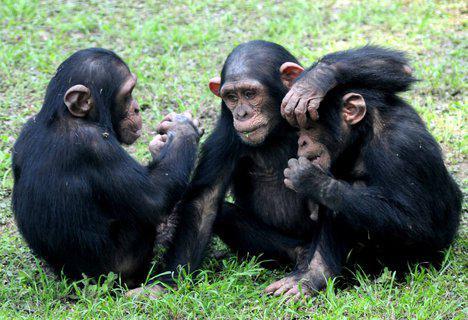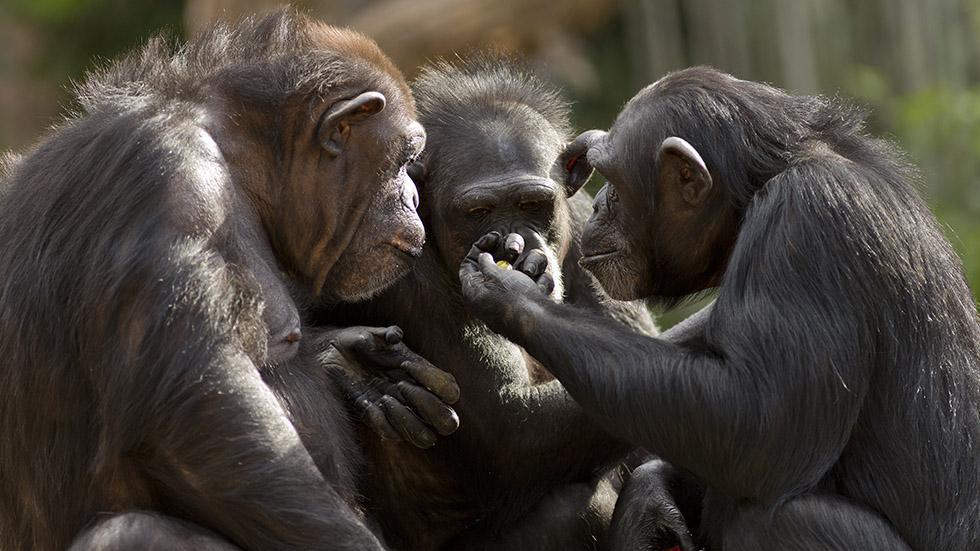The first image is the image on the left, the second image is the image on the right. For the images shown, is this caption "Three juvenile chimps all sit in a row on the ground in the left image." true? Answer yes or no. Yes. The first image is the image on the left, the second image is the image on the right. Given the left and right images, does the statement "An ape is covering it's own face with at least one hand in the right image." hold true? Answer yes or no. No. 